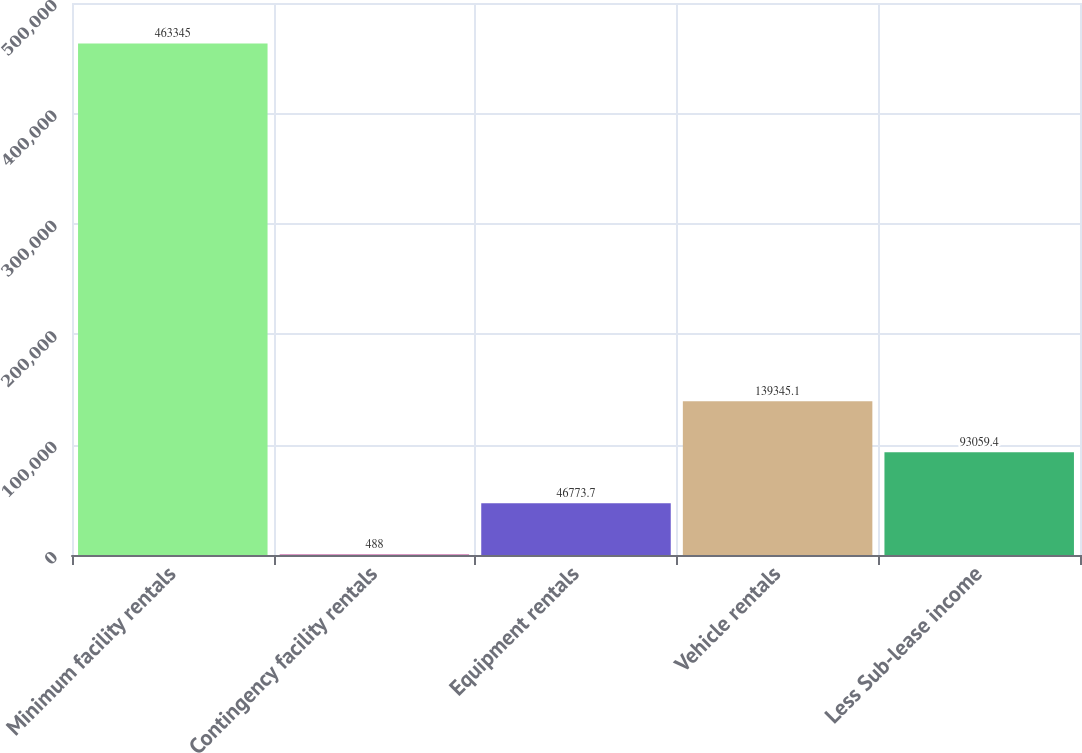Convert chart. <chart><loc_0><loc_0><loc_500><loc_500><bar_chart><fcel>Minimum facility rentals<fcel>Contingency facility rentals<fcel>Equipment rentals<fcel>Vehicle rentals<fcel>Less Sub-lease income<nl><fcel>463345<fcel>488<fcel>46773.7<fcel>139345<fcel>93059.4<nl></chart> 